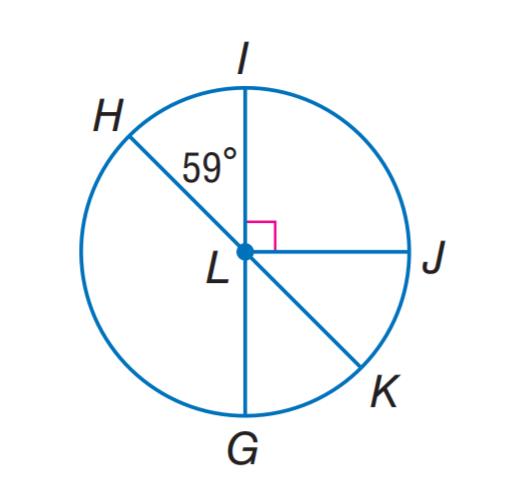Answer the mathemtical geometry problem and directly provide the correct option letter.
Question: H K and I G are diameters of \odot L. Find m \widehat H G K.
Choices: A: 121 B: 160 C: 180 D: 200 C 